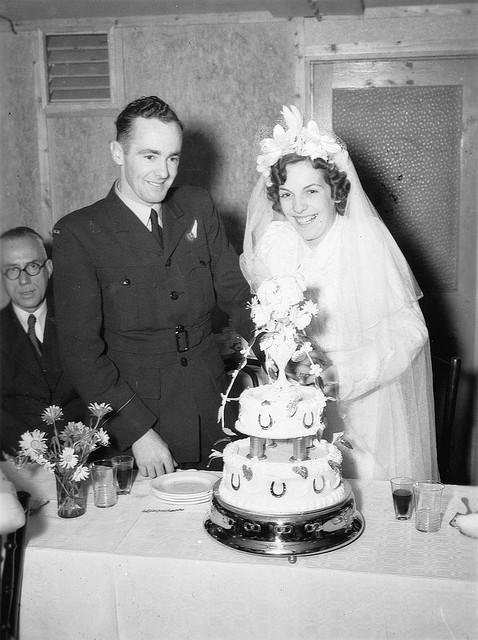What is the couple doing?
Quick response, please. Cutting cake. How many ladies faces are there?
Short answer required. 1. Is someone getting married?
Short answer required. Yes. Is this vase of flowers being used as a centerpiece?
Answer briefly. No. What mood are the couple in?
Answer briefly. Happy. Are these people single?
Answer briefly. No. Is this a vintage picture?
Give a very brief answer. Yes. Is this high fashion?
Answer briefly. No. 